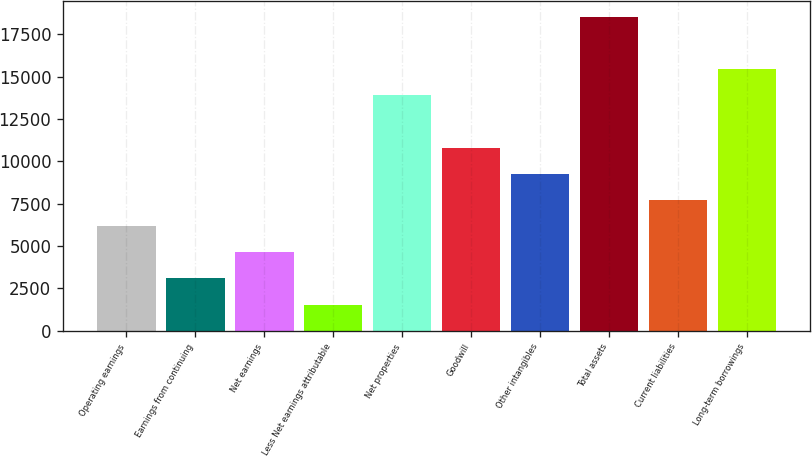Convert chart to OTSL. <chart><loc_0><loc_0><loc_500><loc_500><bar_chart><fcel>Operating earnings<fcel>Earnings from continuing<fcel>Net earnings<fcel>Less Net earnings attributable<fcel>Net properties<fcel>Goodwill<fcel>Other intangibles<fcel>Total assets<fcel>Current liabilities<fcel>Long-term borrowings<nl><fcel>6183.93<fcel>3092.91<fcel>4638.42<fcel>1547.4<fcel>13911.5<fcel>10820.5<fcel>9274.95<fcel>18548<fcel>7729.44<fcel>15457<nl></chart> 